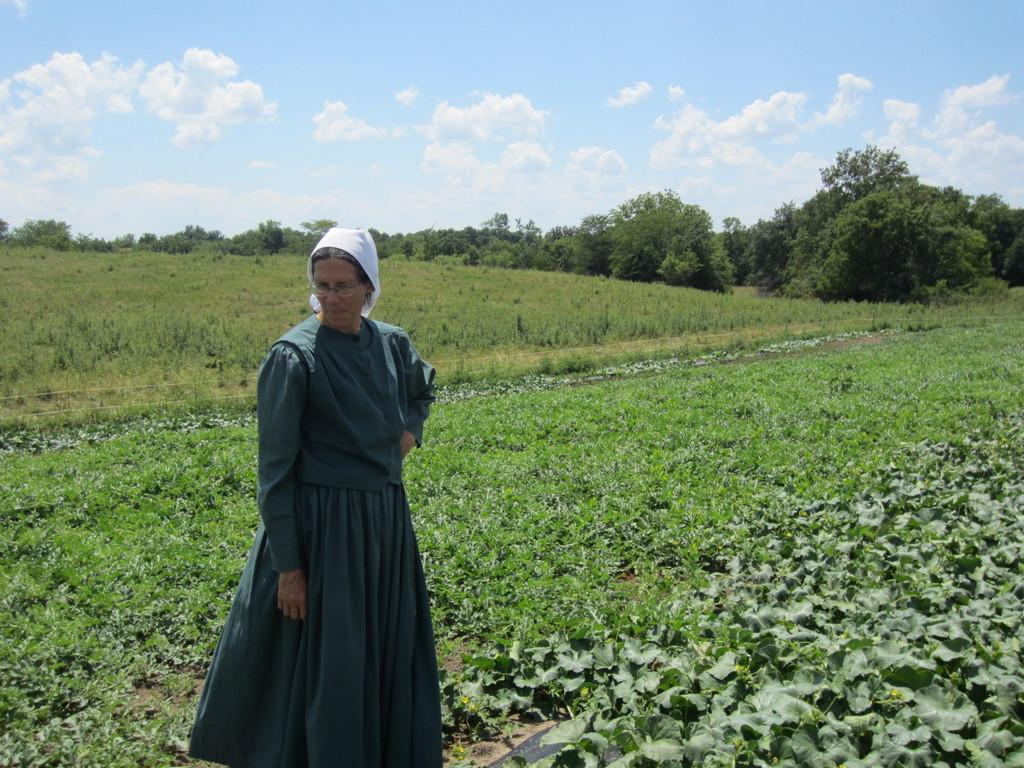What is the main subject of the image? There is a woman standing in the image. What type of environment is depicted in the image? There are plants that resemble a field in the image, and there are trees in the background. What is visible at the top of the image? The sky is visible at the top of the image. Reasoning: Let' Let's think step by step in order to produce the conversation. We start by identifying the main subject of the image, which is the woman standing. Then, we describe the environment in which she is standing, noting the presence of plants, trees, and the sky. Each question is designed to elicit a specific detail about the image that is known from the provided facts. Absurd Question/Answer: What type of print is visible on the jeans the woman is wearing in the image? There is no information about the woman's clothing, including jeans, in the image. What kind of cake is being served on the table in the image? There is no table or cake present in the image. What type of print is visible on the jeans the woman is wearing in the image? There is no information about the woman's clothing, including jeans, in the image. What kind of cake is being served on the table in the image? There is no table or cake present in the image. 